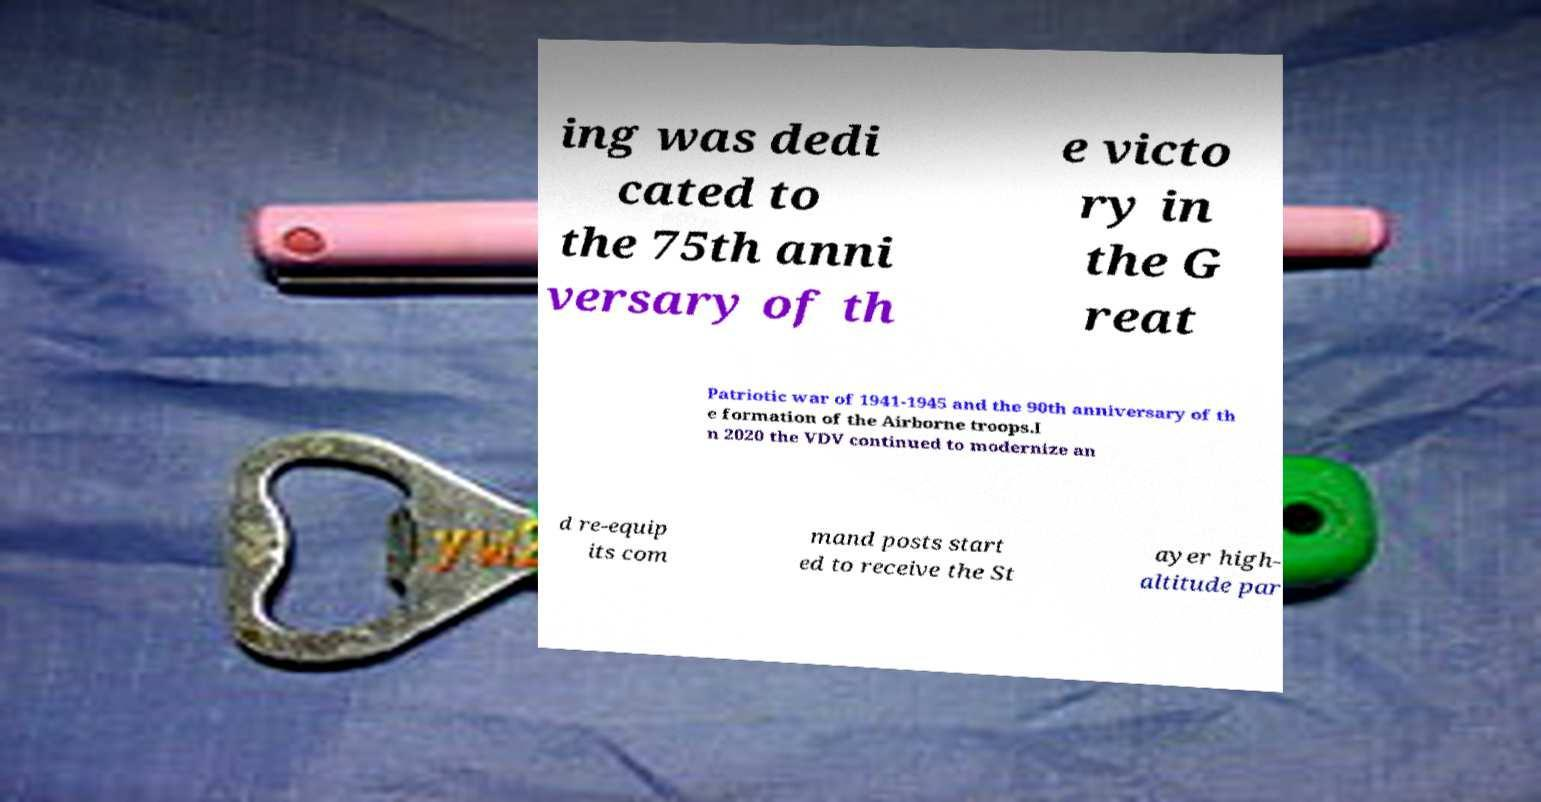I need the written content from this picture converted into text. Can you do that? ing was dedi cated to the 75th anni versary of th e victo ry in the G reat Patriotic war of 1941-1945 and the 90th anniversary of th e formation of the Airborne troops.I n 2020 the VDV continued to modernize an d re-equip its com mand posts start ed to receive the St ayer high- altitude par 